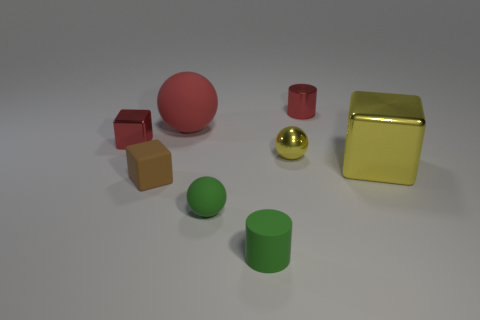What shape is the small object that is the same color as the small metallic block?
Provide a short and direct response. Cylinder. How many things are big brown rubber objects or tiny things to the right of the tiny red block?
Provide a succinct answer. 5. Do the yellow metallic thing that is right of the small yellow ball and the cylinder that is to the right of the small green matte cylinder have the same size?
Ensure brevity in your answer.  No. What number of big yellow metal things are the same shape as the tiny yellow metallic thing?
Make the answer very short. 0. What shape is the brown object that is made of the same material as the green ball?
Offer a terse response. Cube. There is a small cube that is in front of the tiny red thing that is on the left side of the cube in front of the large yellow metal object; what is its material?
Provide a short and direct response. Rubber. Does the yellow sphere have the same size as the rubber ball that is in front of the red sphere?
Your answer should be very brief. Yes. What material is the other big thing that is the same shape as the brown rubber thing?
Offer a very short reply. Metal. There is a metallic block to the right of the tiny ball that is left of the rubber object that is in front of the green sphere; what is its size?
Your answer should be compact. Large. Does the yellow cube have the same size as the rubber cylinder?
Ensure brevity in your answer.  No. 